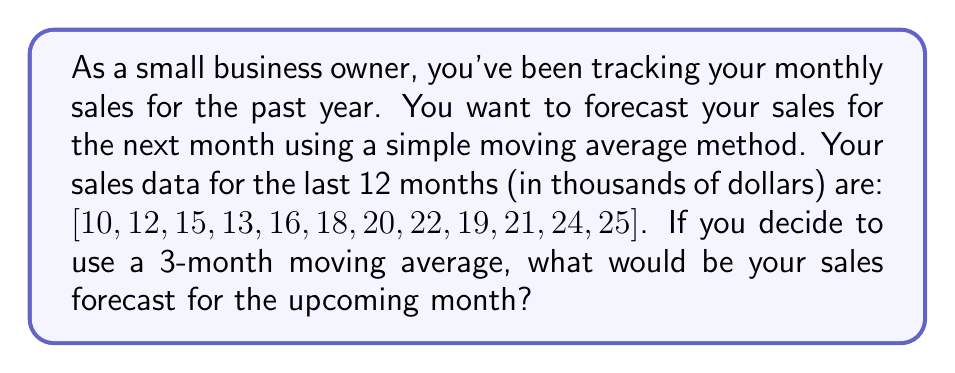Can you solve this math problem? To solve this problem, we'll use the simple moving average method, which is a common technique in time series analysis for forecasting. Here's a step-by-step explanation:

1. Understand the simple moving average (SMA):
   The n-month SMA is calculated by taking the average of the most recent n months of data.

2. Identify the relevant data:
   We're using a 3-month moving average, so we only need the last 3 months of data:
   [21, 24, 25]

3. Calculate the 3-month SMA:
   $$SMA = \frac{\text{Sum of last 3 months}}{\text{Number of months}}$$
   
   $$SMA = \frac{21 + 24 + 25}{3}$$

4. Perform the calculation:
   $$SMA = \frac{70}{3} = 23.33$$

5. Round the result:
   In business contexts, it's common to round to two decimal places.
   23.33 rounds to 23.33

Therefore, based on the 3-month simple moving average, the sales forecast for the upcoming month is $23,330 (or 23.33 thousand dollars).

Note: This method assumes that recent trends will continue, which may not always be the case. In real-world scenarios, you might want to consider more advanced forecasting techniques or factor in other variables that could affect sales.
Answer: $23.33 thousand (or $23,330) 